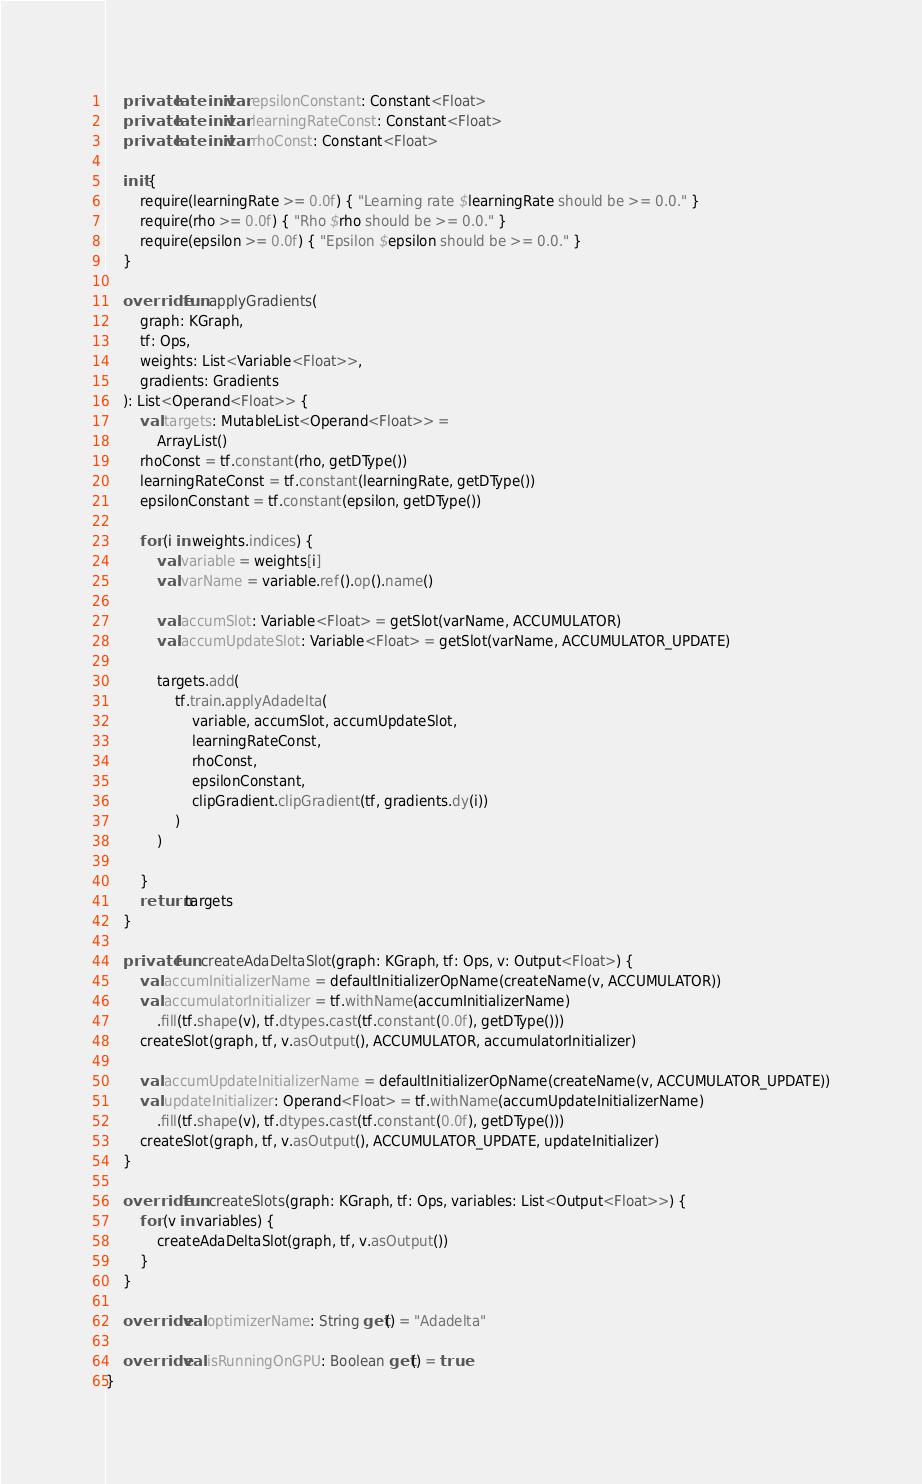Convert code to text. <code><loc_0><loc_0><loc_500><loc_500><_Kotlin_>    private lateinit var epsilonConstant: Constant<Float>
    private lateinit var learningRateConst: Constant<Float>
    private lateinit var rhoConst: Constant<Float>

    init {
        require(learningRate >= 0.0f) { "Learning rate $learningRate should be >= 0.0." }
        require(rho >= 0.0f) { "Rho $rho should be >= 0.0." }
        require(epsilon >= 0.0f) { "Epsilon $epsilon should be >= 0.0." }
    }

    override fun applyGradients(
        graph: KGraph,
        tf: Ops,
        weights: List<Variable<Float>>,
        gradients: Gradients
    ): List<Operand<Float>> {
        val targets: MutableList<Operand<Float>> =
            ArrayList()
        rhoConst = tf.constant(rho, getDType())
        learningRateConst = tf.constant(learningRate, getDType())
        epsilonConstant = tf.constant(epsilon, getDType())

        for (i in weights.indices) {
            val variable = weights[i]
            val varName = variable.ref().op().name()

            val accumSlot: Variable<Float> = getSlot(varName, ACCUMULATOR)
            val accumUpdateSlot: Variable<Float> = getSlot(varName, ACCUMULATOR_UPDATE)

            targets.add(
                tf.train.applyAdadelta(
                    variable, accumSlot, accumUpdateSlot,
                    learningRateConst,
                    rhoConst,
                    epsilonConstant,
                    clipGradient.clipGradient(tf, gradients.dy(i))
                )
            )

        }
        return targets
    }

    private fun createAdaDeltaSlot(graph: KGraph, tf: Ops, v: Output<Float>) {
        val accumInitializerName = defaultInitializerOpName(createName(v, ACCUMULATOR))
        val accumulatorInitializer = tf.withName(accumInitializerName)
            .fill(tf.shape(v), tf.dtypes.cast(tf.constant(0.0f), getDType()))
        createSlot(graph, tf, v.asOutput(), ACCUMULATOR, accumulatorInitializer)

        val accumUpdateInitializerName = defaultInitializerOpName(createName(v, ACCUMULATOR_UPDATE))
        val updateInitializer: Operand<Float> = tf.withName(accumUpdateInitializerName)
            .fill(tf.shape(v), tf.dtypes.cast(tf.constant(0.0f), getDType()))
        createSlot(graph, tf, v.asOutput(), ACCUMULATOR_UPDATE, updateInitializer)
    }

    override fun createSlots(graph: KGraph, tf: Ops, variables: List<Output<Float>>) {
        for (v in variables) {
            createAdaDeltaSlot(graph, tf, v.asOutput())
        }
    }

    override val optimizerName: String get() = "Adadelta"

    override val isRunningOnGPU: Boolean get() = true
}
</code> 